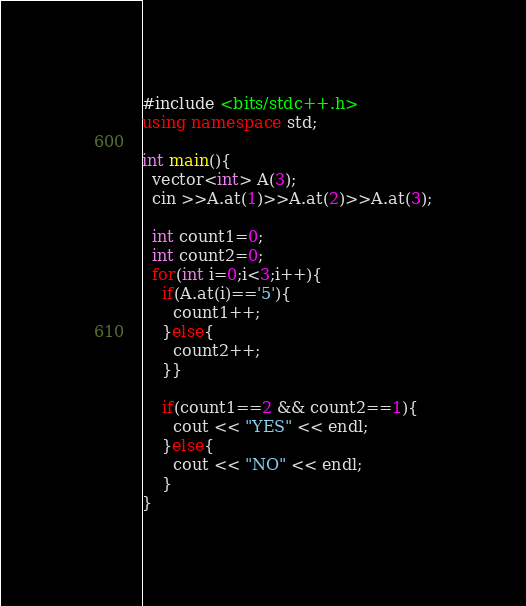<code> <loc_0><loc_0><loc_500><loc_500><_C++_>#include <bits/stdc++.h>
using namespace std;

int main(){
  vector<int> A(3);
  cin >>A.at(1)>>A.at(2)>>A.at(3);
  
  int count1=0;
  int count2=0;
  for(int i=0;i<3;i++){
    if(A.at(i)=='5'){
      count1++;
    }else{
      count2++;
    }}
    
    if(count1==2 && count2==1){
      cout << "YES" << endl;
    }else{
      cout << "NO" << endl;
    }
}</code> 